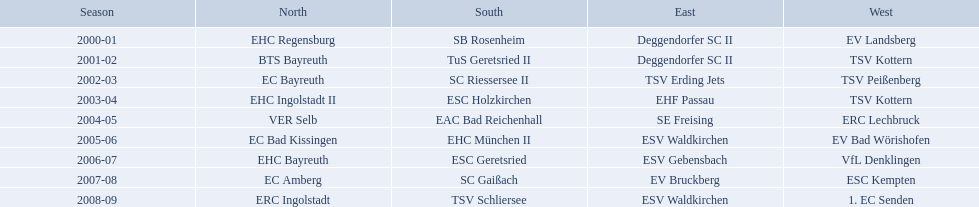Which teams have won in the bavarian ice hockey leagues between 2000 and 2009? EHC Regensburg, SB Rosenheim, Deggendorfer SC II, EV Landsberg, BTS Bayreuth, TuS Geretsried II, TSV Kottern, EC Bayreuth, SC Riessersee II, TSV Erding Jets, TSV Peißenberg, EHC Ingolstadt II, ESC Holzkirchen, EHF Passau, TSV Kottern, VER Selb, EAC Bad Reichenhall, SE Freising, ERC Lechbruck, EC Bad Kissingen, EHC München II, ESV Waldkirchen, EV Bad Wörishofen, EHC Bayreuth, ESC Geretsried, ESV Gebensbach, VfL Denklingen, EC Amberg, SC Gaißach, EV Bruckberg, ESC Kempten, ERC Ingolstadt, TSV Schliersee, ESV Waldkirchen, 1. EC Senden. Which of these winning teams have won the north? EHC Regensburg, BTS Bayreuth, EC Bayreuth, EHC Ingolstadt II, VER Selb, EC Bad Kissingen, EHC Bayreuth, EC Amberg, ERC Ingolstadt. Which of the teams that won the north won in the 2000/2001 season? EHC Regensburg. In their respective years, which teams came out on top in the north? 2000-01, EHC Regensburg, BTS Bayreuth, EC Bayreuth, EHC Ingolstadt II, VER Selb, EC Bad Kissingen, EHC Bayreuth, EC Amberg, ERC Ingolstadt. Which team claimed victory solely in the 2000-01 season? EHC Regensburg. From 2000 to 2009, which teams claimed victory in the bavarian ice hockey leagues? EHC Regensburg, SB Rosenheim, Deggendorfer SC II, EV Landsberg, BTS Bayreuth, TuS Geretsried II, TSV Kottern, EC Bayreuth, SC Riessersee II, TSV Erding Jets, TSV Peißenberg, EHC Ingolstadt II, ESC Holzkirchen, EHF Passau, TSV Kottern, VER Selb, EAC Bad Reichenhall, SE Freising, ERC Lechbruck, EC Bad Kissingen, EHC München II, ESV Waldkirchen, EV Bad Wörishofen, EHC Bayreuth, ESC Geretsried, ESV Gebensbach, VfL Denklingen, EC Amberg, SC Gaißach, EV Bruckberg, ESC Kempten, ERC Ingolstadt, TSV Schliersee, ESV Waldkirchen, 1. EC Senden. Of these winning teams, which ones triumphed in the northern division? EHC Regensburg, BTS Bayreuth, EC Bayreuth, EHC Ingolstadt II, VER Selb, EC Bad Kissingen, EHC Bayreuth, EC Amberg, ERC Ingolstadt. Additionally, which of these northern division winners captured the title in the 2000/2001 season? EHC Regensburg. 